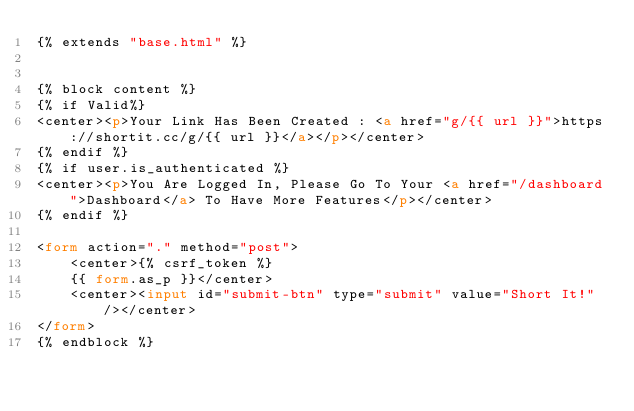Convert code to text. <code><loc_0><loc_0><loc_500><loc_500><_HTML_>{% extends "base.html" %}


{% block content %}
{% if Valid%}
<center><p>Your Link Has Been Created : <a href="g/{{ url }}">https://shortit.cc/g/{{ url }}</a></p></center>
{% endif %}
{% if user.is_authenticated %}
<center><p>You Are Logged In, Please Go To Your <a href="/dashboard">Dashboard</a> To Have More Features</p></center>
{% endif %}

<form action="." method="post">
    <center>{% csrf_token %}
    {{ form.as_p }}</center>
    <center><input id="submit-btn" type="submit" value="Short It!" /></center>
</form>
{% endblock %}</code> 